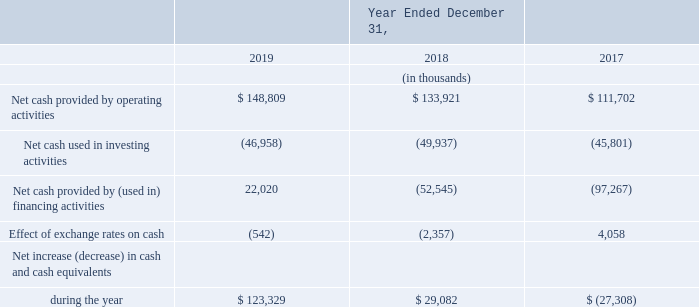Liquidity and Capital Resources
In assessing our short term and long term liquidity, management reviews and analyzes our current cash balances, short-term investments, accounts receivable, accounts payable, accrued liabilities, capital expenditure and operating expense commitments, and required finance lease, interest and debt payments and other obligations. In assessing our short term and long term liquidity, management reviews and analyzes our current cash balances, short-term investments, accounts receivable, accounts payable, accrued liabilities, capital expenditure and operating expense commitments, and required finance lease, interest and debt payments and other obligations.
The following table sets forth our consolidated cash flows.
Net Cash Provided By Operating Activities. Our primary source of operating cash is receipts from our customers who are billed on a monthly basis for our services. Our primary uses of operating cash are payments made to our vendors, employees and interest payments made to our finance lease vendors and our note holders. Our changes in cash provided by operating activities are primarily due to changes in our operating profit and changes in our interest payments. Cash provided by operating activities for 2019, 2018 and 2017 includes interest payments on our note obligations of $38.0 million, $32.7 million and $30.8 million, respectively.
Net Cash Used In Investing Activities. Our primary use of investing cash is for purchases of property and equipment. These amounts were $47.0 million, $49.9 million and $45.8 million for 2019, 2018 and 2017, respectively. The annual changes in purchases of property and equipment are primarily due to the timing and scope of our network expansion activities including geographic expansion and adding buildings to our network. In 2019, 2018 and 2017 we obtained $11.3 million, $9.9 million and $9.0 million, respectively, of network equipment and software in non-cash exchanges for notes payable under an installment payment agreement.
Net Cash Provided By (Used In) Financing Activities. Our primary uses of cash for financing activities are for dividend payments, stock purchases and principal payments under our finance lease obligations. Amounts paid under our stock buyback program were $6.6 million for 2018 and $1.8 million for 2017. There were no stock purchases for 2019. During 2019, 2018 and 2017 we paid $112.6 million, $97.9 million and $81.7 million, respectively, for our quarterly dividend payments. Our quarterly dividend payments have increased due to regular quarterly increases in our quarterly dividend per share amounts. Principal payments under our finance lease obligations were $9.1 million, $10.3 million and $11.2 million for 2019, 2018 and 2017, respectively, and are impacted by the timing and extent of our network expansion activities. Our financing activities also include proceeds from and repayments of our debt offerings. In June 2019 we received net proceeds of $152.1 million from the issuance of our €135.0 million of 2024 Notes. In August 2018 we received net proceeds of $69.9 million from the issuance of our $70.0 million of senior secured notes. Total installment payment agreement principal payments were $10.0 million, $9.4 million and $3.8 million for 2019, 2018 and 2017, respectively.
What are the respective net cash provided by operating activities in 2017 and 2018?
Answer scale should be: thousand. $ 111,702, $ 133,921. What are the respective net cash provided by operating activities in 2018 and 2019?
Answer scale should be: thousand. $ 133,921, $ 148,809. What are the respective net cash used in investing activities in 2017 and 2018?
Answer scale should be: thousand. 45,801, 49,937. What is the average net cash provided by operating activities in 2017 and 2018?
Answer scale should be: thousand. (111,702 + 133,921)/2 
Answer: 122811.5. What is the average net cash provided by operating activities in 2018 and 2019?
Answer scale should be: thousand. (133,921 + 148,809)/2 
Answer: 141365. What is the average net cash used in investing activities between 2017 and 2018?
Answer scale should be: thousand. (45,801 + 49,937)/2 
Answer: 47869. 